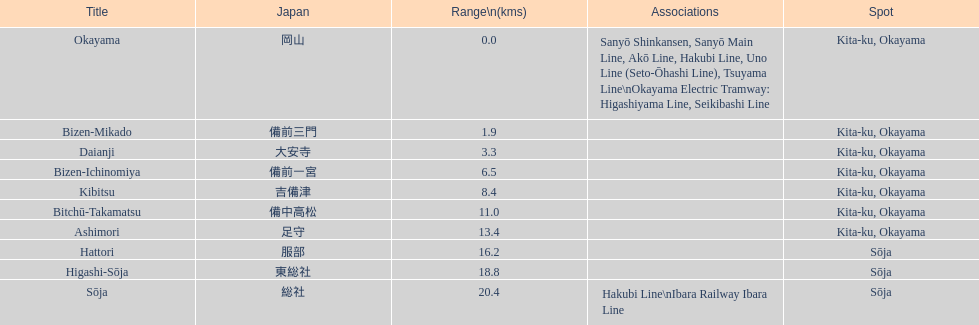Which has a distance less than 3.0 kilometers? Bizen-Mikado. 